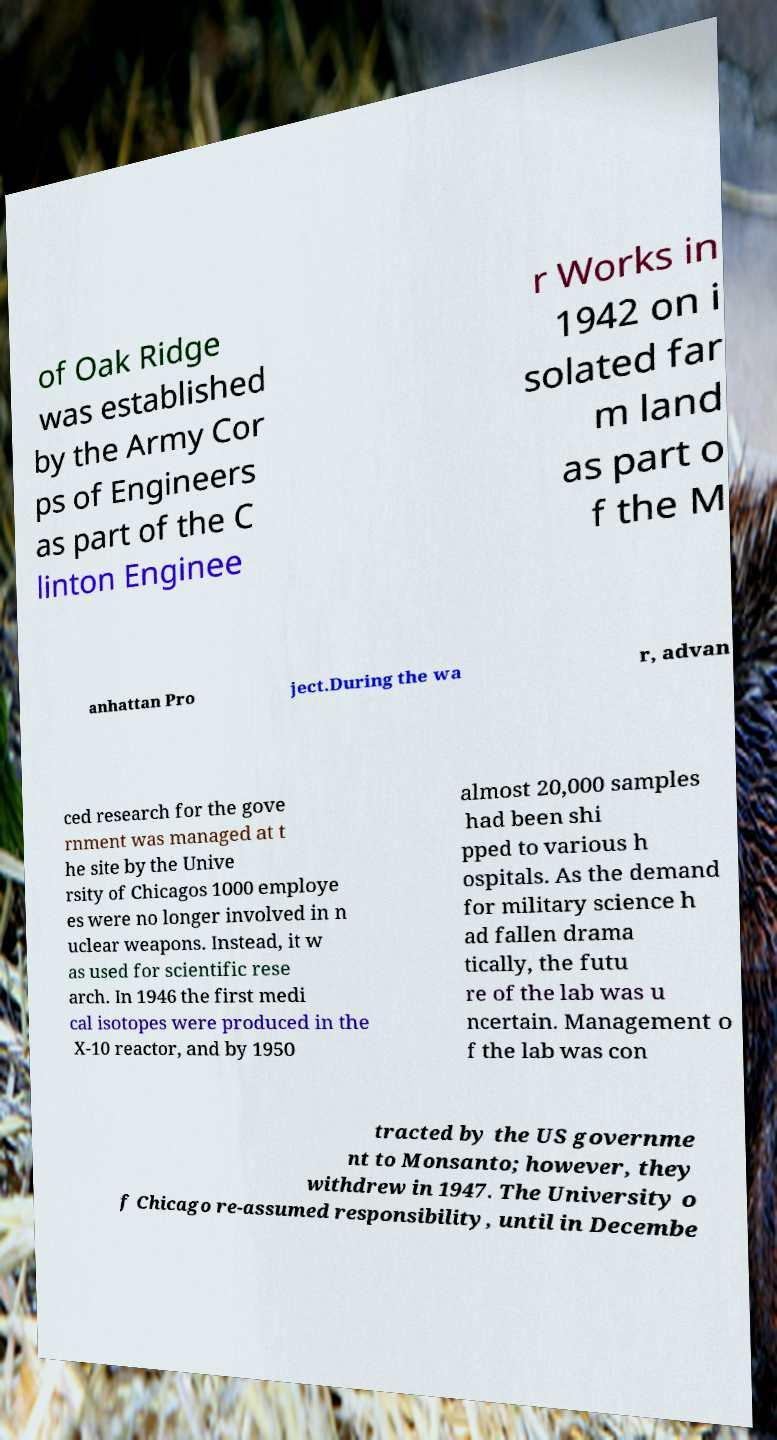There's text embedded in this image that I need extracted. Can you transcribe it verbatim? of Oak Ridge was established by the Army Cor ps of Engineers as part of the C linton Enginee r Works in 1942 on i solated far m land as part o f the M anhattan Pro ject.During the wa r, advan ced research for the gove rnment was managed at t he site by the Unive rsity of Chicagos 1000 employe es were no longer involved in n uclear weapons. Instead, it w as used for scientific rese arch. In 1946 the first medi cal isotopes were produced in the X-10 reactor, and by 1950 almost 20,000 samples had been shi pped to various h ospitals. As the demand for military science h ad fallen drama tically, the futu re of the lab was u ncertain. Management o f the lab was con tracted by the US governme nt to Monsanto; however, they withdrew in 1947. The University o f Chicago re-assumed responsibility, until in Decembe 